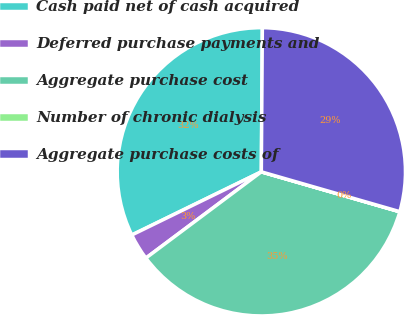<chart> <loc_0><loc_0><loc_500><loc_500><pie_chart><fcel>Cash paid net of cash acquired<fcel>Deferred purchase payments and<fcel>Aggregate purchase cost<fcel>Number of chronic dialysis<fcel>Aggregate purchase costs of<nl><fcel>32.34%<fcel>2.99%<fcel>35.32%<fcel>0.01%<fcel>29.35%<nl></chart> 